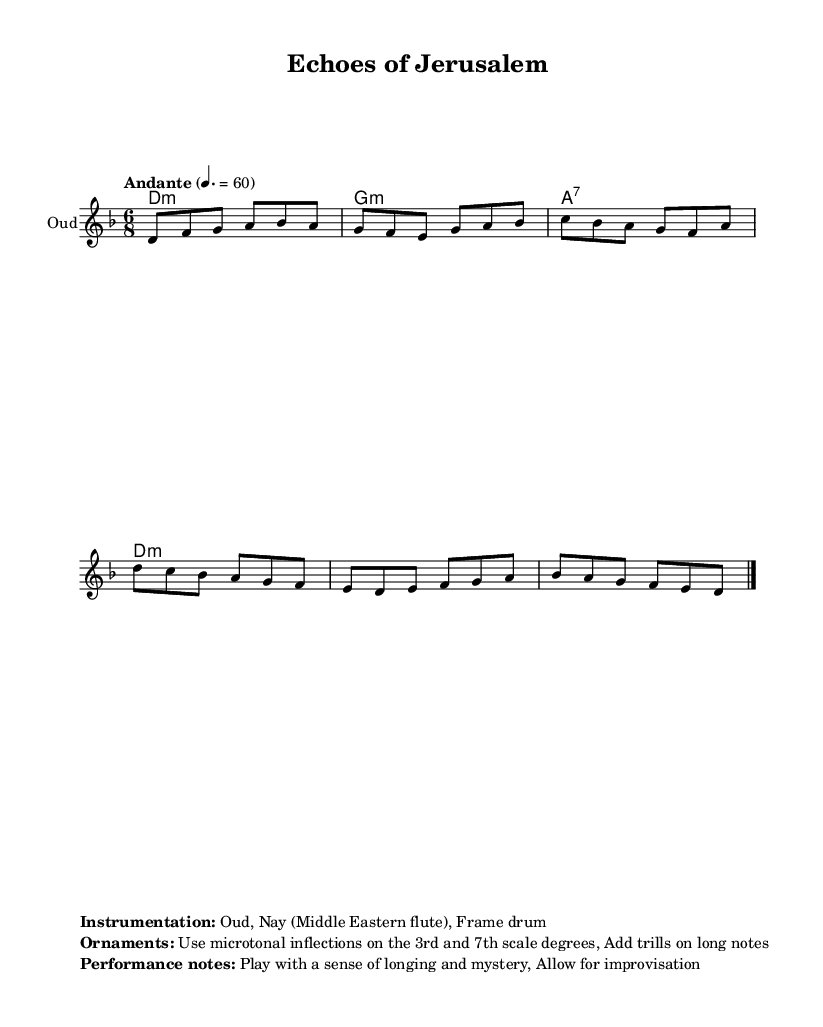What is the key signature of this music? The key signature is D minor, which has one flat (B flat) indicated at the beginning of the score.
Answer: D minor What is the time signature of the piece? The time signature is 6/8, which can be identified by the two numbers at the beginning of the notation where 6 is the number of beats in a measure and 8 represents the note value that receives one count.
Answer: 6/8 What tempo marking is indicated in the score? The tempo marking is "Andante," which suggests a moderate walking pace. The specific number, 60, indicates the metronome marking, meaning 60 beats per minute.
Answer: Andante How many measures are present in the melody? There are a total of 6 measures in the melody, each separated by vertical lines marking the end of each measure.
Answer: 6 What instruments are indicated for performance? The instrumentation listed includes Oud, Nay, and Frame drum, showcasing the Middle Eastern influences. This is highlighted in the markup section under "Instrumentation."
Answer: Oud, Nay, Frame drum What type of inflections are suggested for ornaments in the performance notes? The performance notes suggest using microtonal inflections specifically on the 3rd and 7th scale degrees, which is characteristic of Middle Eastern music for added expressive qualities.
Answer: Microtonal inflections What is the primary mood suggested for performance? The performance notes suggest playing with a sense of longing and mystery, setting an emotional context for interpretation.
Answer: Longing and mystery 